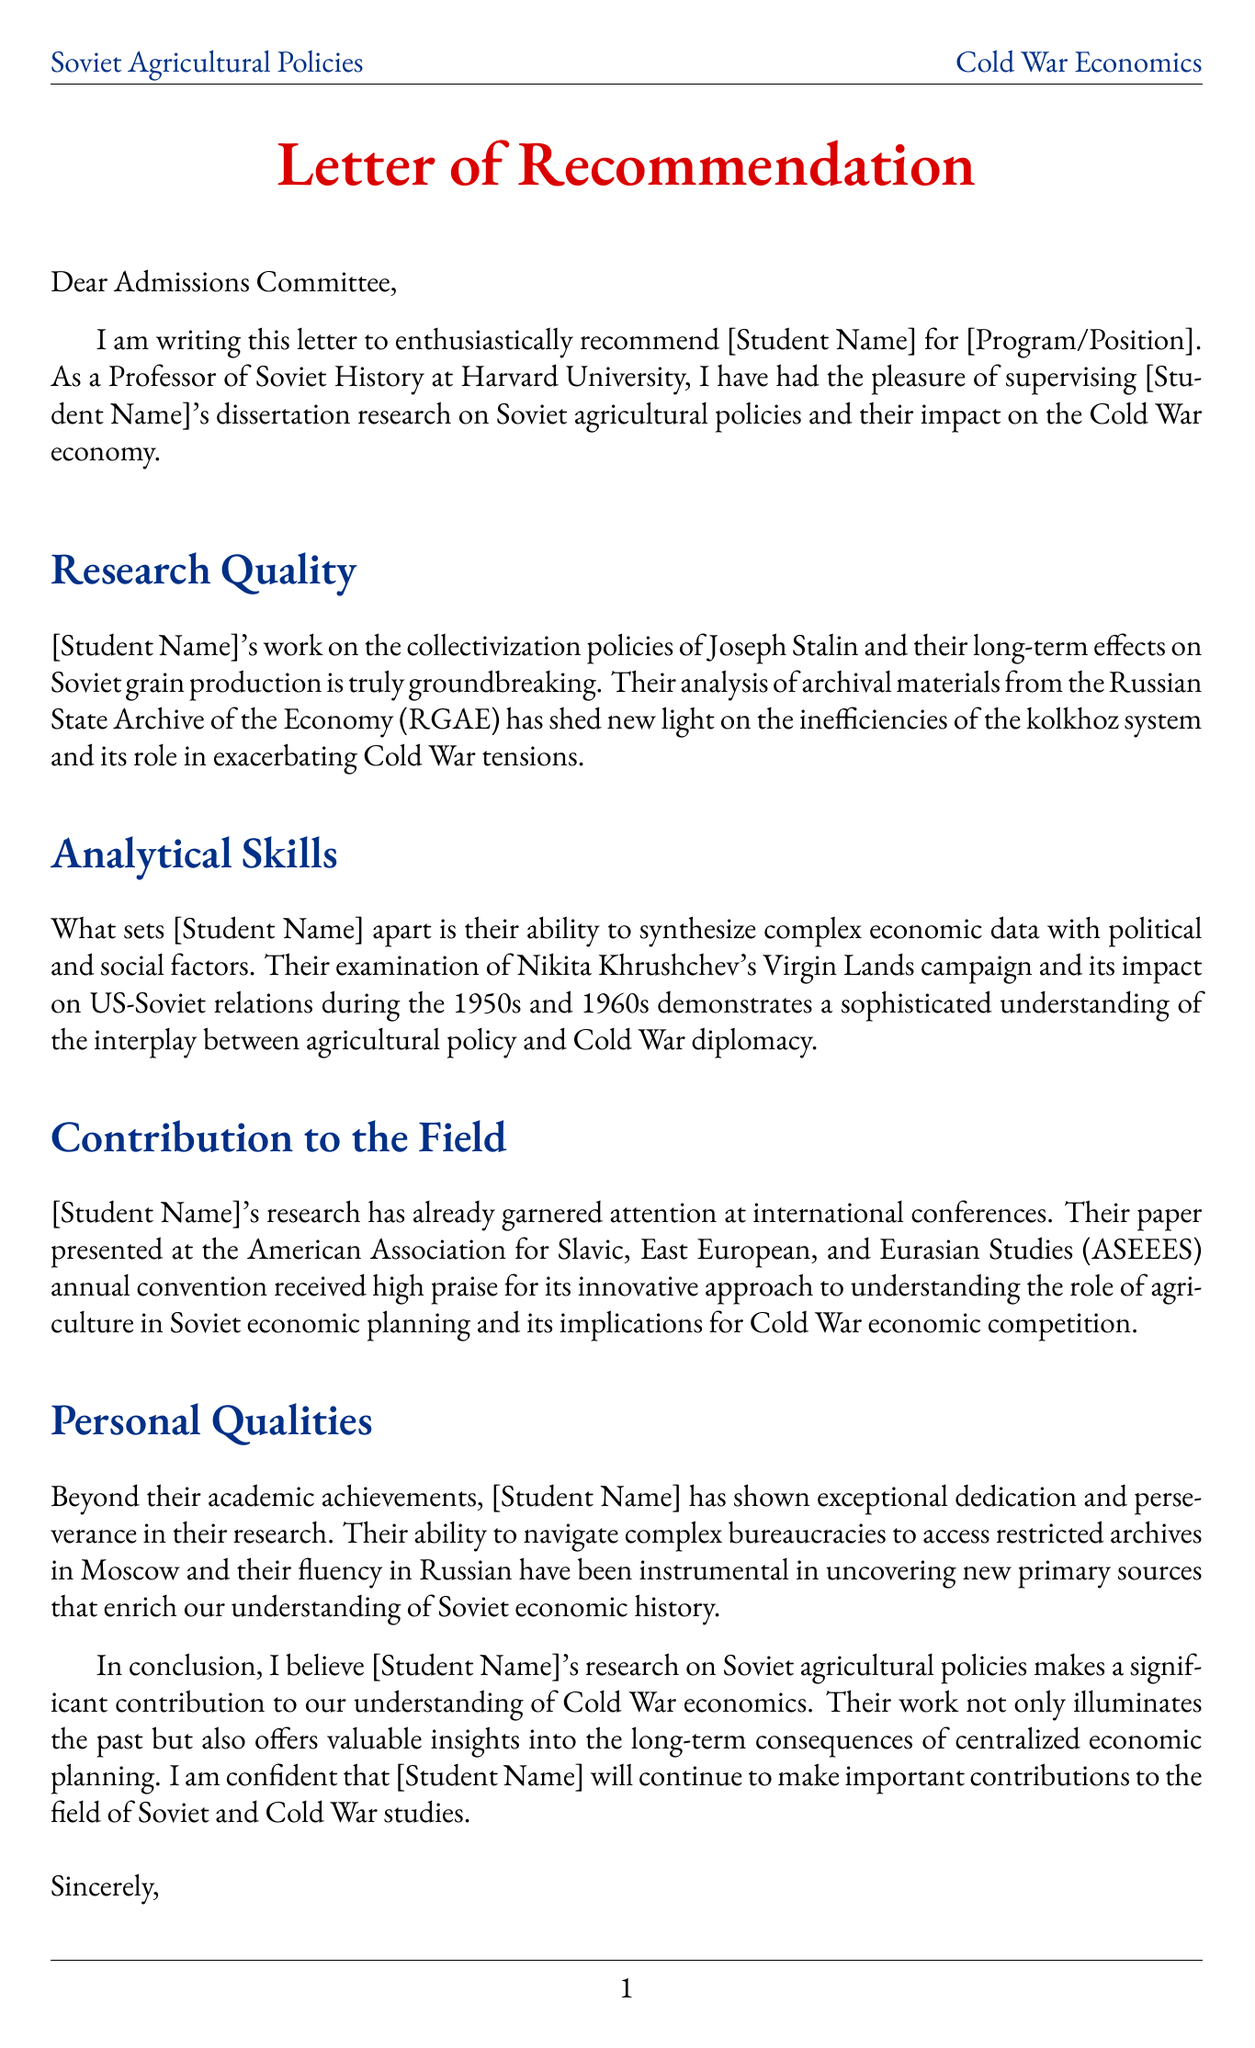What is the student's name? The letter template uses [Student Name] as a placeholder for the actual student's name.
Answer: [Student Name] Who is the author of the letter? The author is identified in the closing section of the letter.
Answer: Dr. Sheila Fitzpatrick What is the position of the letter's author? The letter states the author's title at the end.
Answer: Bernadotte E. Schmitt Distinguished Service Professor Emerita What are the main research topics of the student? The letter highlights specific areas of the student's research in the body paragraphs.
Answer: Stalin's collectivization policies, Soviet grain production statistics, Khrushchev's Virgin Lands campaign, Impact of agricultural policies on US-Soviet relations Which archive did the student use for their research? The letter mentions the specific archive from which the student conducted research.
Answer: Russian State Archive of the Economy (RGAE) What conference did the student present their research at? The letter identifies the conference where the student presented their work.
Answer: American Association for Slavic, East European, and Eurasian Studies (ASEEES) annual convention What language is the student fluent in? The letter indicates a specific skill of the student regarding language.
Answer: Russian What agricultural policy is associated with Joseph Stalin? The letter refers to a specific policy implemented by Stalin.
Answer: collectivization policies What was Khrushchev's initiative to cultivate land in the USSR called? The letter discusses a notable campaign initiated by Khrushchev.
Answer: Virgin Lands campaign 